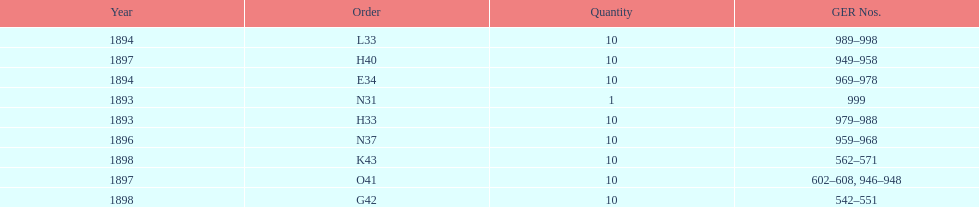What is the order of the last year listed? K43. 